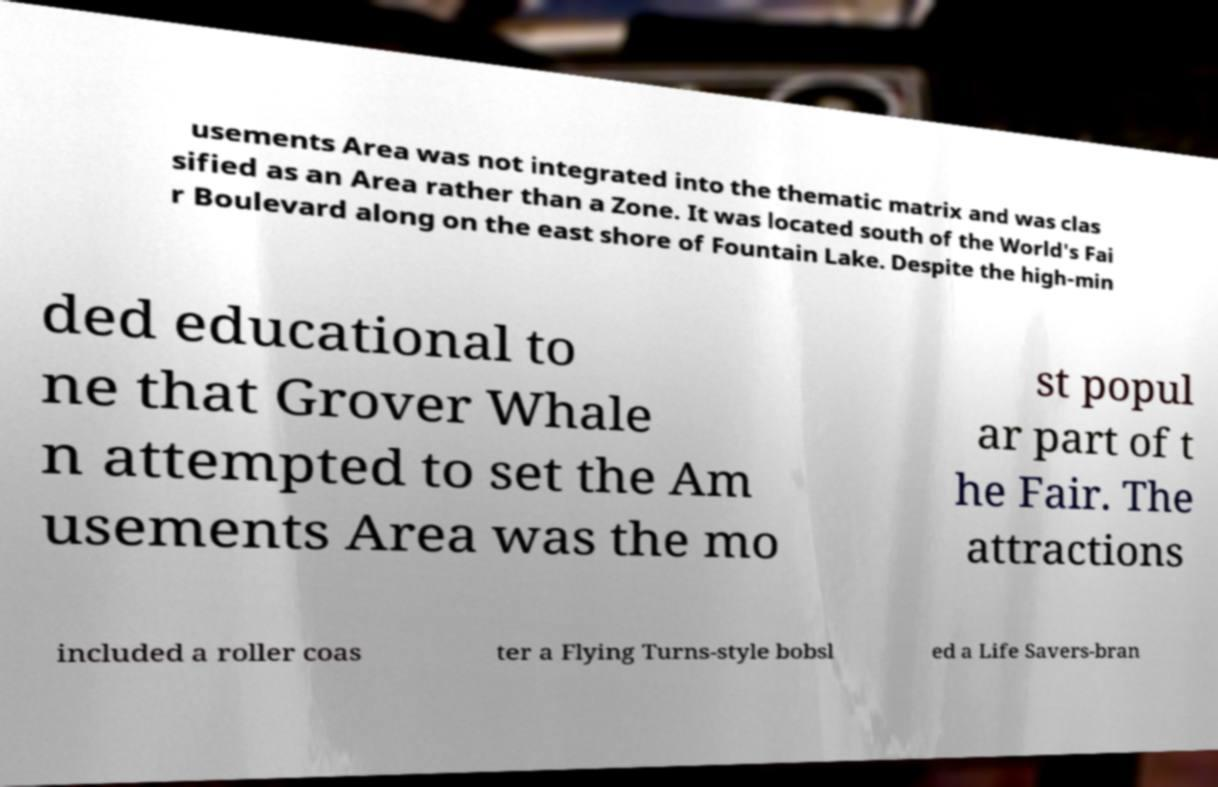What messages or text are displayed in this image? I need them in a readable, typed format. usements Area was not integrated into the thematic matrix and was clas sified as an Area rather than a Zone. It was located south of the World's Fai r Boulevard along on the east shore of Fountain Lake. Despite the high-min ded educational to ne that Grover Whale n attempted to set the Am usements Area was the mo st popul ar part of t he Fair. The attractions included a roller coas ter a Flying Turns-style bobsl ed a Life Savers-bran 